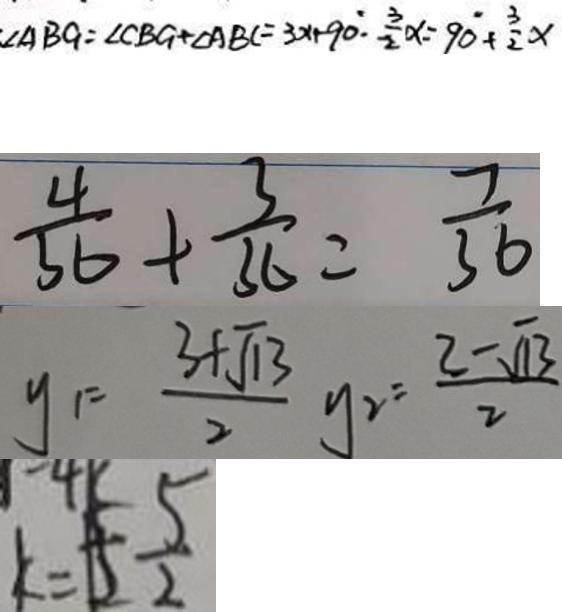<formula> <loc_0><loc_0><loc_500><loc_500>\cdot \angle A B G = \angle C B G + \angle A B C = 3 x + 9 0 ^ { \circ } \cdot \frac { 3 } { 2 } \alpha = 9 0 + \frac { 3 } { 2 } x 
 \frac { 4 } { 3 6 } + \frac { 3 } { 3 6 } = \frac { 7 } { 3 6 } 
 y _ { 1 } = \frac { 3 + \sqrt { 1 3 } } { 2 } y _ { 2 } = \frac { 3 - \sqrt { 1 3 } } { 2 } 
 k = 1 5 \frac { 5 } { 2 }</formula> 